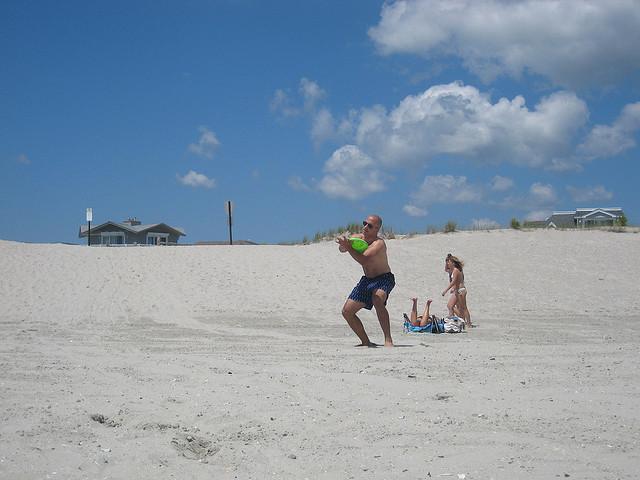How many cows are facing the ocean?
Give a very brief answer. 0. 